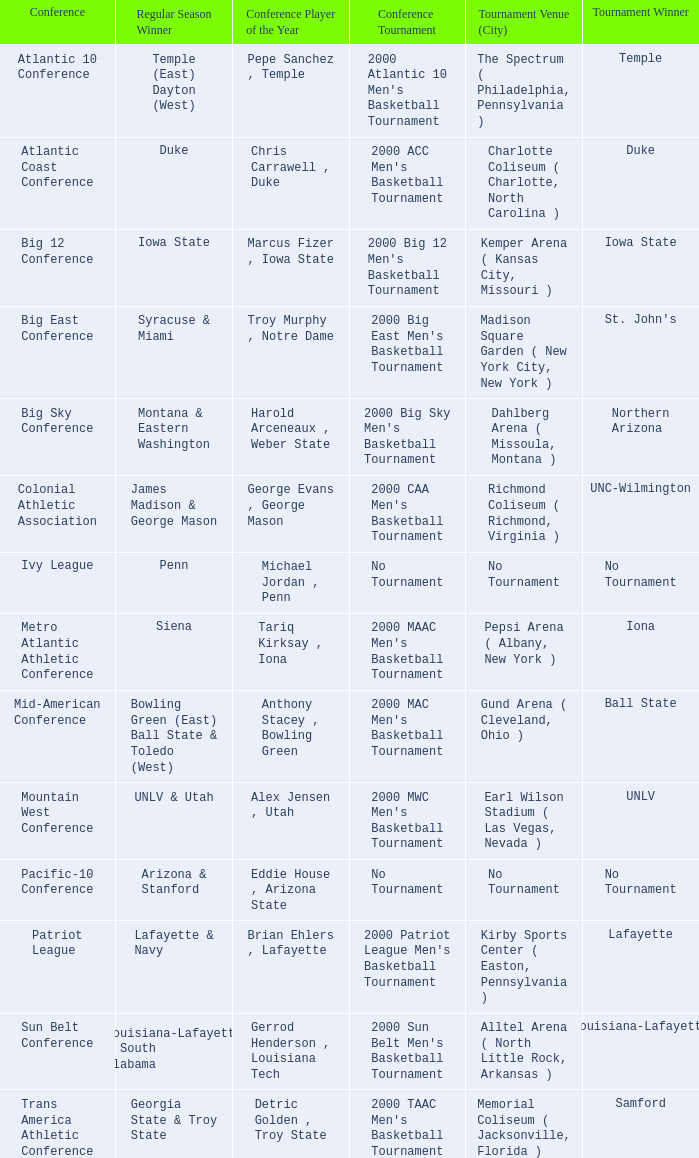Where was the Ivy League conference tournament? No Tournament. 